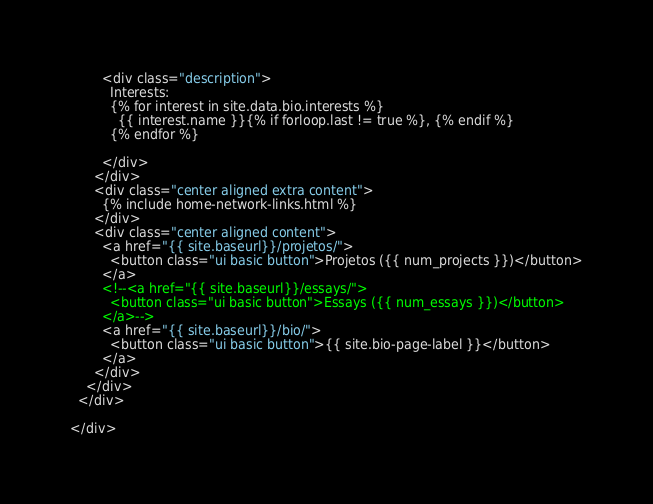<code> <loc_0><loc_0><loc_500><loc_500><_HTML_>        <div class="description">
          Interests:
          {% for interest in site.data.bio.interests %}
            {{ interest.name }}{% if forloop.last != true %}, {% endif %}
          {% endfor %}

        </div>
      </div>
      <div class="center aligned extra content">
        {% include home-network-links.html %}
      </div>
      <div class="center aligned content">
        <a href="{{ site.baseurl}}/projetos/">
          <button class="ui basic button">Projetos ({{ num_projects }})</button>
        </a>
        <!--<a href="{{ site.baseurl}}/essays/">
          <button class="ui basic button">Essays ({{ num_essays }})</button>
        </a>-->
        <a href="{{ site.baseurl}}/bio/">
          <button class="ui basic button">{{ site.bio-page-label }}</button>
        </a>
      </div>
    </div>
  </div>

</div>
</code> 